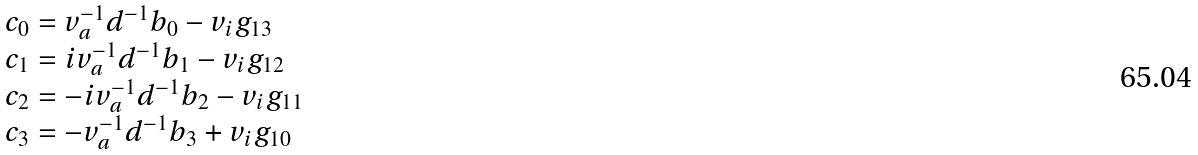Convert formula to latex. <formula><loc_0><loc_0><loc_500><loc_500>\begin{array} { l } c _ { 0 } = v _ { a } ^ { - 1 } d ^ { - 1 } b _ { 0 } - v _ { i } g _ { 1 3 } \\ c _ { 1 } = i v _ { a } ^ { - 1 } d ^ { - 1 } b _ { 1 } - v _ { i } g _ { 1 2 } \\ c _ { 2 } = - i v _ { a } ^ { - 1 } d ^ { - 1 } b _ { 2 } - v _ { i } g _ { 1 1 } \\ c _ { 3 } = - v _ { a } ^ { - 1 } d ^ { - 1 } b _ { 3 } + v _ { i } g _ { 1 0 } \end{array}</formula> 